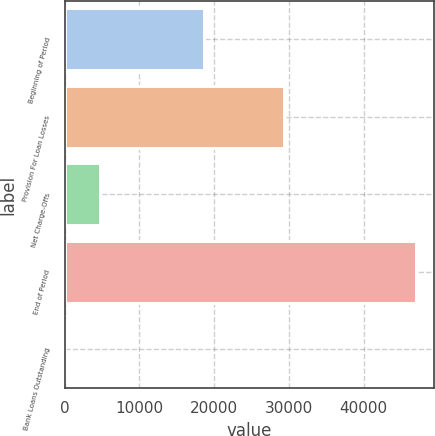Convert chart. <chart><loc_0><loc_0><loc_500><loc_500><bar_chart><fcel>Beginning of Period<fcel>Provision For Loan Losses<fcel>Net Charge-Offs<fcel>End of Period<fcel>Bank Loans Outstanding<nl><fcel>18694<fcel>29410<fcel>4703.1<fcel>47022<fcel>1<nl></chart> 